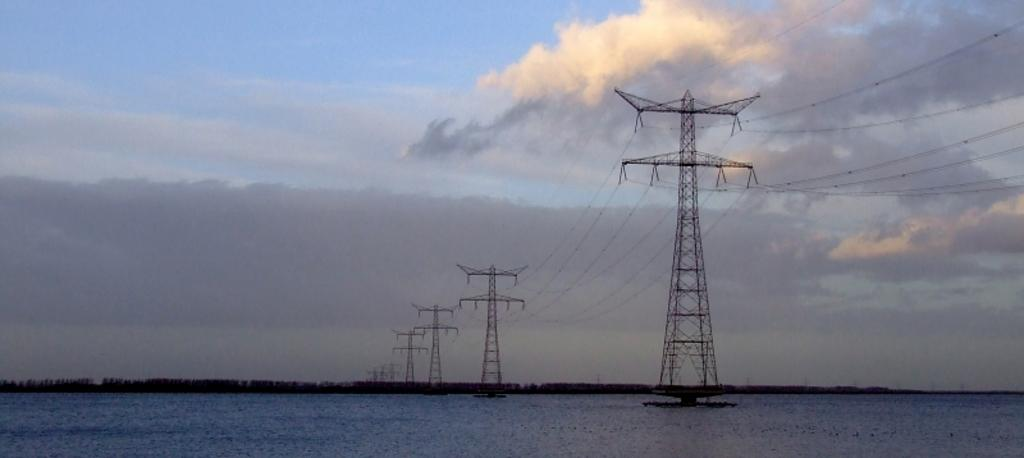What type of structures are present in the image? There are electric poles in the image. What is connected to the electric poles? There are electric cables in the image. What natural element is visible in the image? There is water visible in the image. What type of vegetation is present in the image? There are trees in the image. What is visible in the background of the image? The sky is visible in the image, and there are clouds in the sky. Where is the lake located in the image? There is no lake present in the image. Can you see a horse in the image? There is no horse present in the image. What type of window treatment is visible in the image? There is no curtain or window treatment visible in the image. 